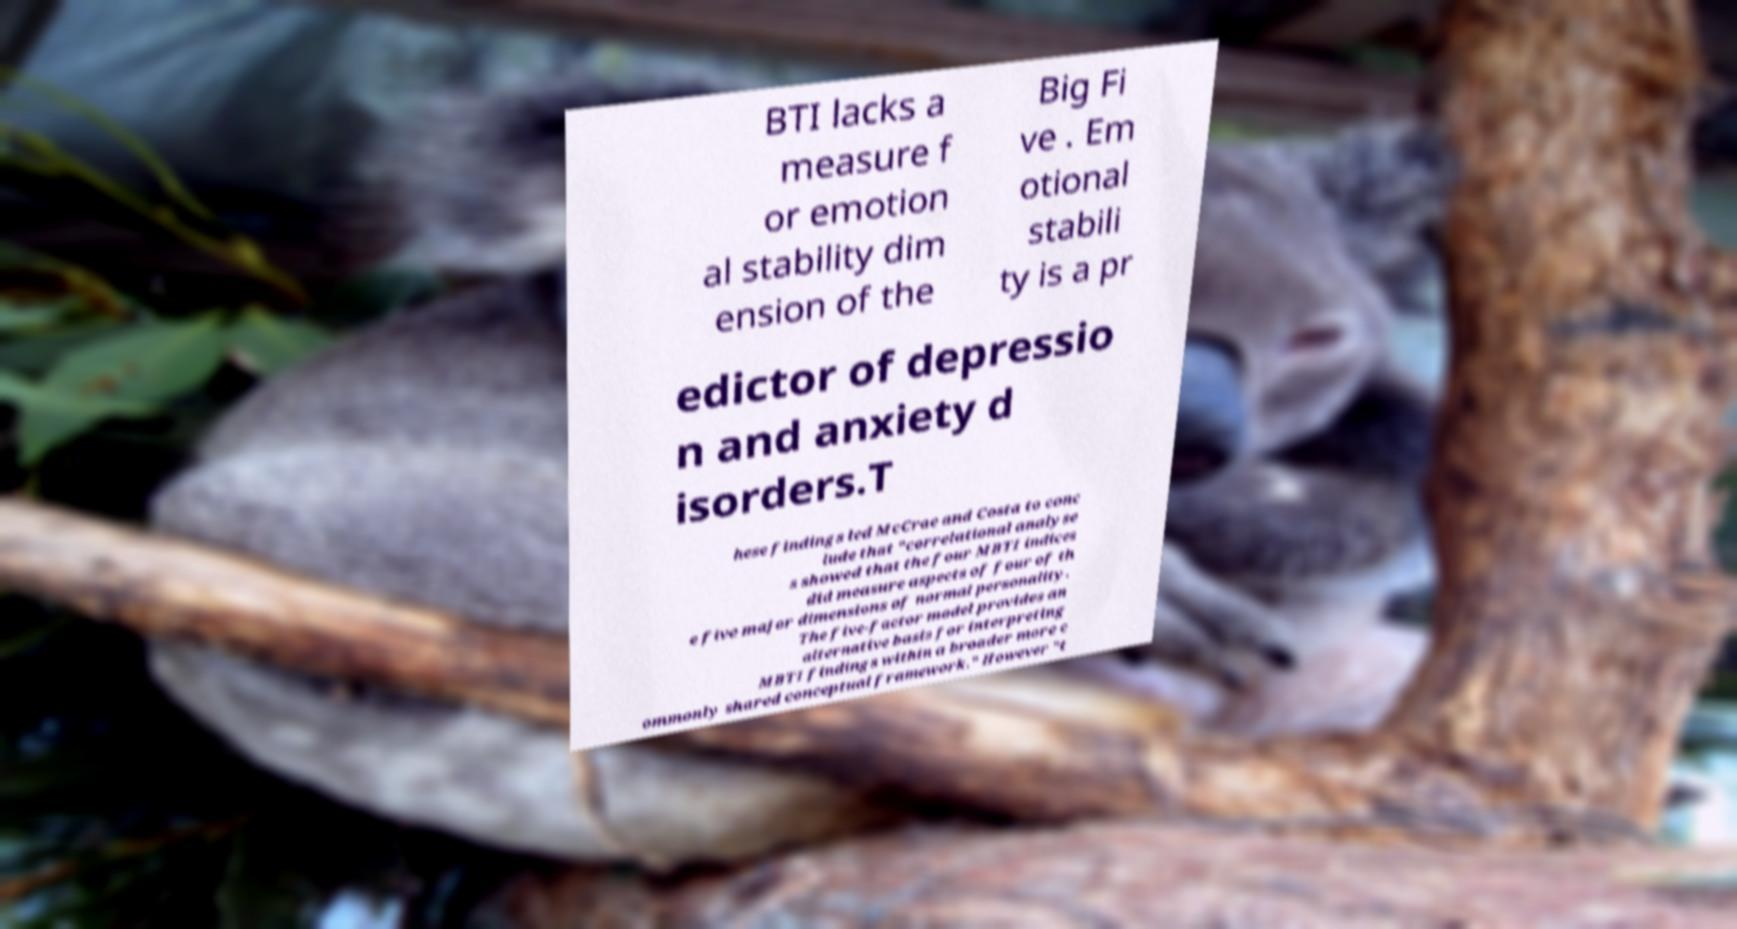Could you extract and type out the text from this image? BTI lacks a measure f or emotion al stability dim ension of the Big Fi ve . Em otional stabili ty is a pr edictor of depressio n and anxiety d isorders.T hese findings led McCrae and Costa to conc lude that "correlational analyse s showed that the four MBTI indices did measure aspects of four of th e five major dimensions of normal personality. The five-factor model provides an alternative basis for interpreting MBTI findings within a broader more c ommonly shared conceptual framework." However "t 